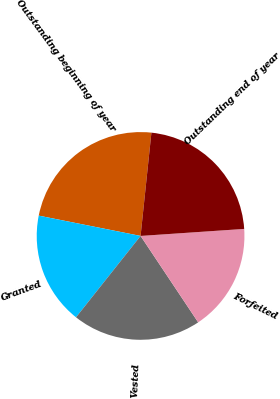Convert chart to OTSL. <chart><loc_0><loc_0><loc_500><loc_500><pie_chart><fcel>Outstanding beginning of year<fcel>Granted<fcel>Vested<fcel>Forfeited<fcel>Outstanding end of year<nl><fcel>23.53%<fcel>17.46%<fcel>20.03%<fcel>16.72%<fcel>22.26%<nl></chart> 